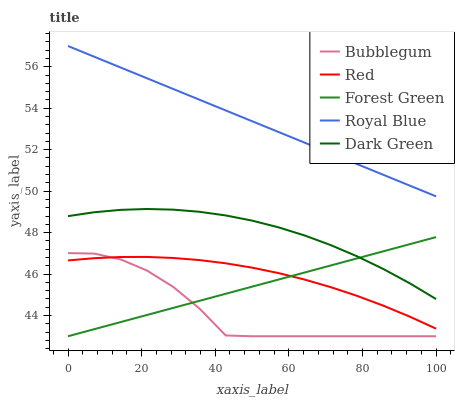Does Bubblegum have the minimum area under the curve?
Answer yes or no. Yes. Does Royal Blue have the maximum area under the curve?
Answer yes or no. Yes. Does Forest Green have the minimum area under the curve?
Answer yes or no. No. Does Forest Green have the maximum area under the curve?
Answer yes or no. No. Is Royal Blue the smoothest?
Answer yes or no. Yes. Is Bubblegum the roughest?
Answer yes or no. Yes. Is Forest Green the smoothest?
Answer yes or no. No. Is Forest Green the roughest?
Answer yes or no. No. Does Forest Green have the lowest value?
Answer yes or no. Yes. Does Red have the lowest value?
Answer yes or no. No. Does Royal Blue have the highest value?
Answer yes or no. Yes. Does Forest Green have the highest value?
Answer yes or no. No. Is Bubblegum less than Royal Blue?
Answer yes or no. Yes. Is Royal Blue greater than Forest Green?
Answer yes or no. Yes. Does Bubblegum intersect Forest Green?
Answer yes or no. Yes. Is Bubblegum less than Forest Green?
Answer yes or no. No. Is Bubblegum greater than Forest Green?
Answer yes or no. No. Does Bubblegum intersect Royal Blue?
Answer yes or no. No. 